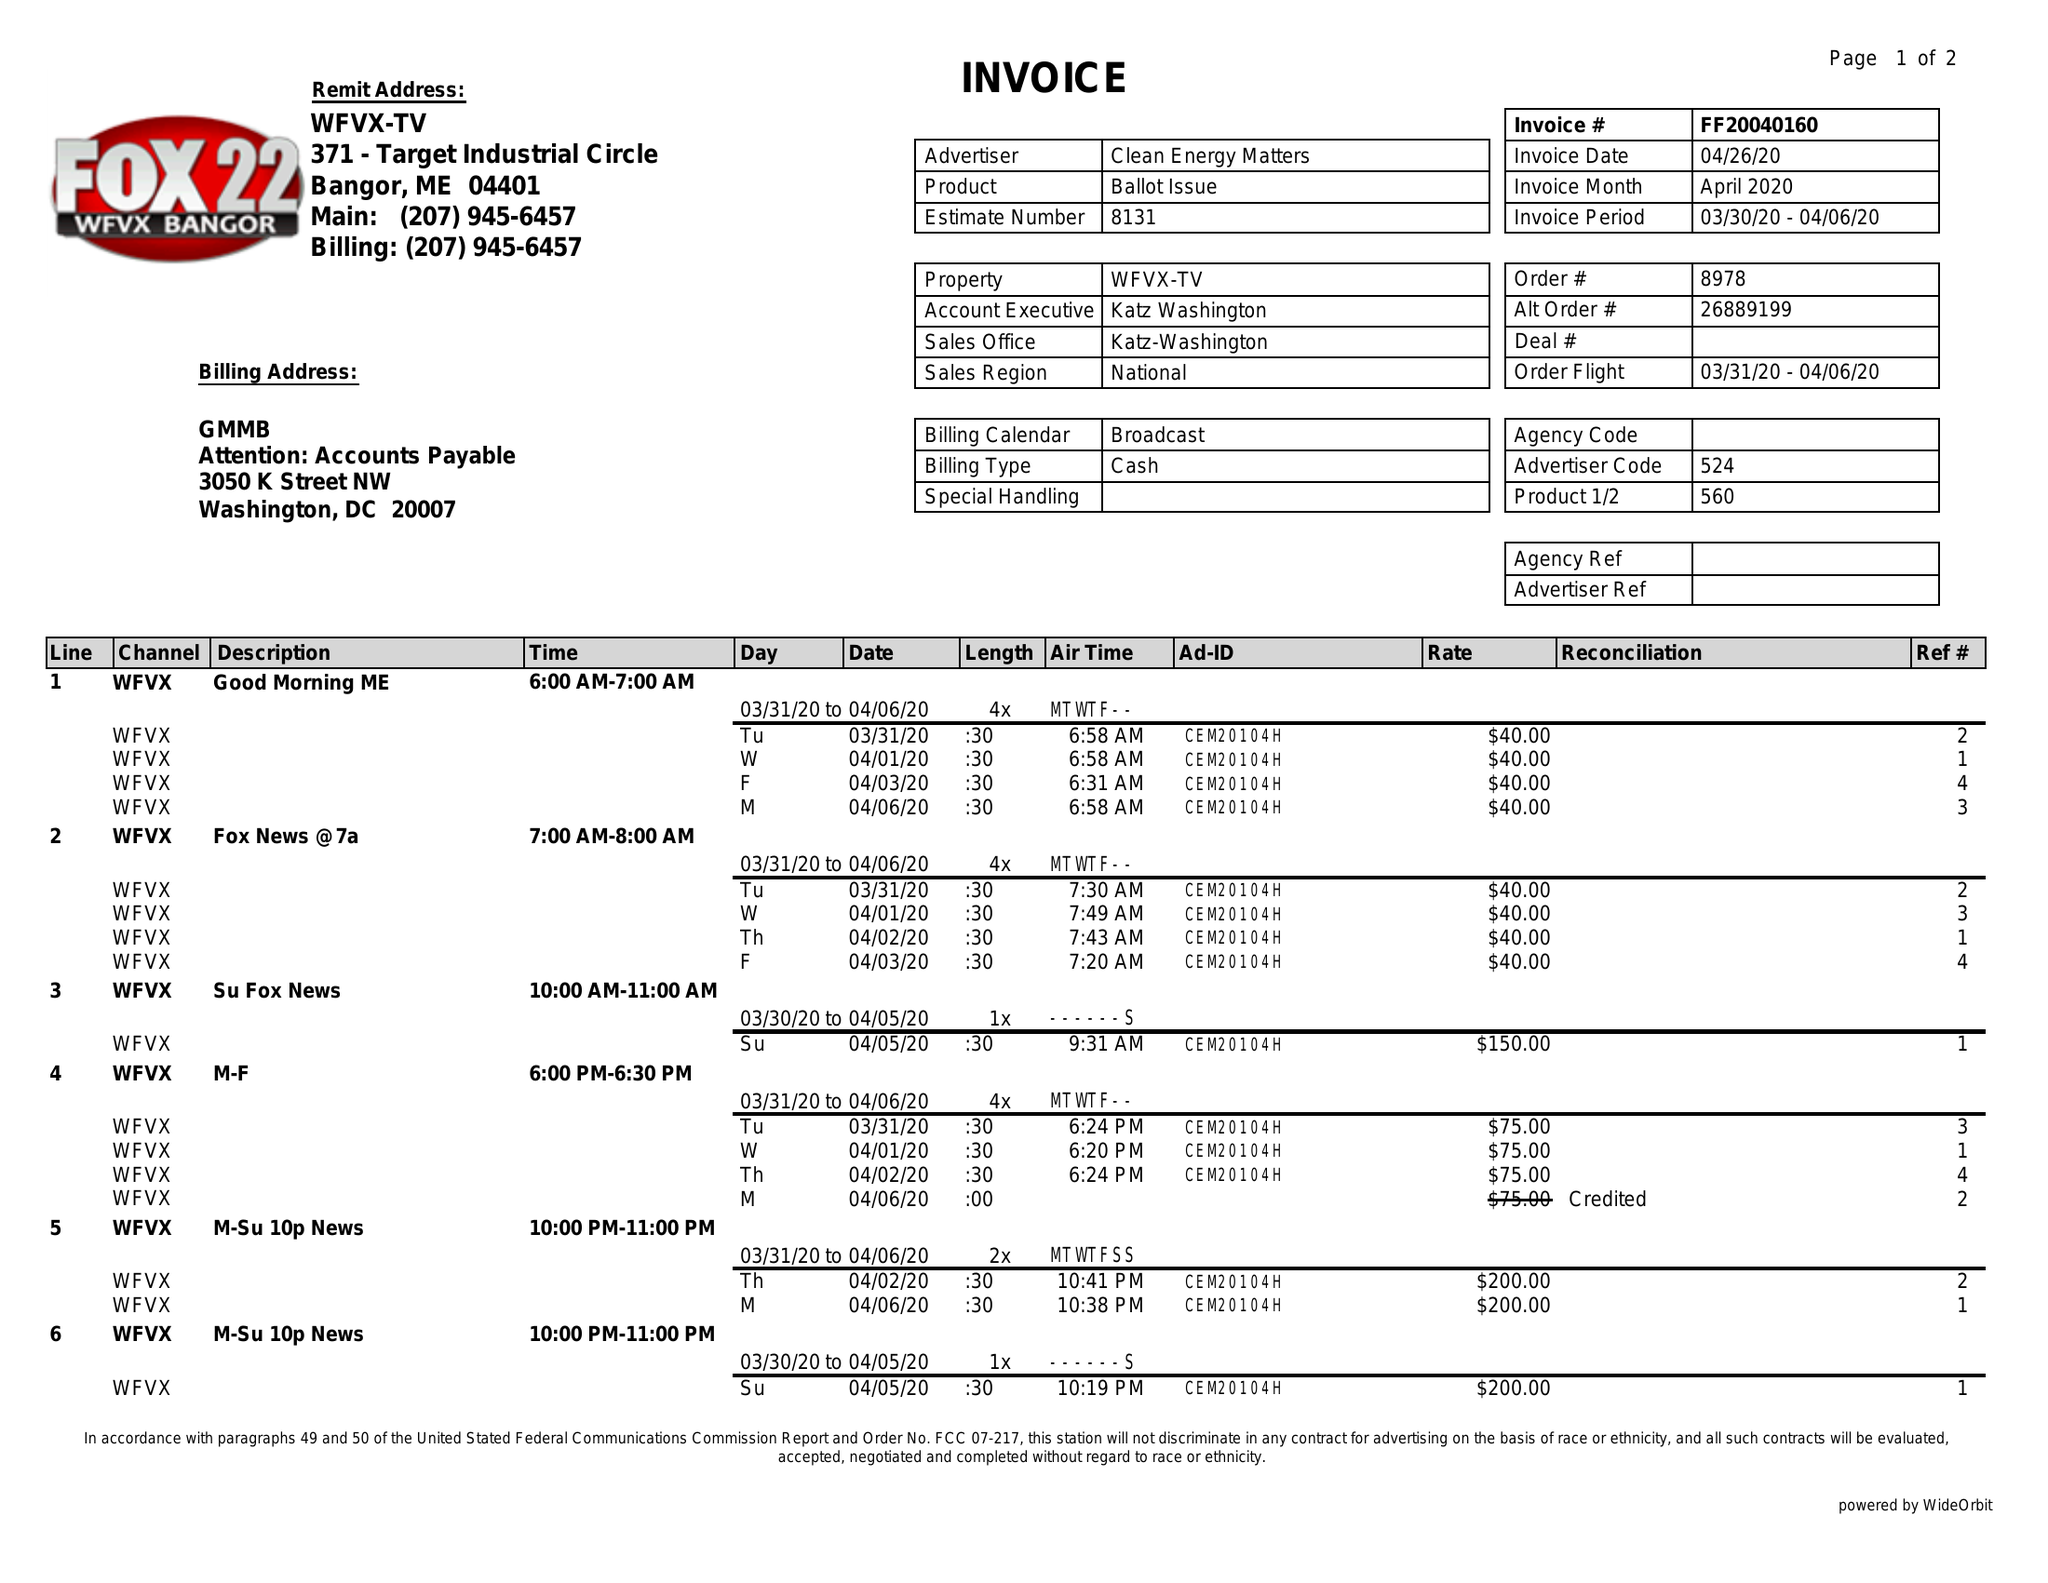What is the value for the flight_from?
Answer the question using a single word or phrase. 03/31/20 